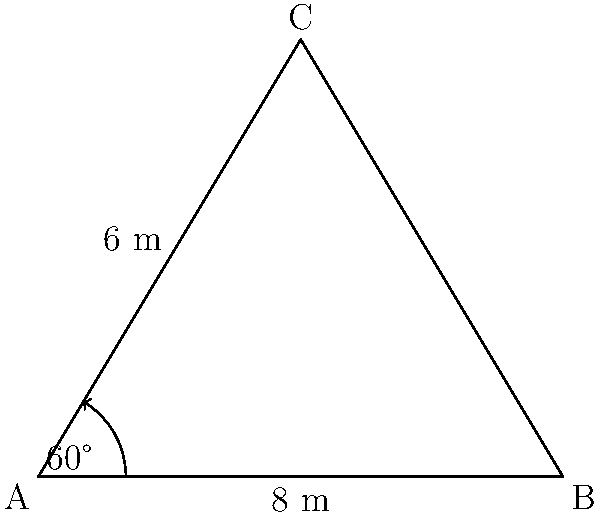In a hospice facility, you're planning to create a triangular garden to provide a peaceful space for patients and their families. Two sides of the garden measure 8 meters and 6 meters, with an included angle of 60°. What is the area of this triangular garden? To find the area of the triangular garden, we can use the formula for the area of a triangle given two sides and the included angle:

$$A = \frac{1}{2}ab\sin(C)$$

Where:
$A$ is the area of the triangle
$a$ and $b$ are the lengths of the two known sides
$C$ is the measure of the included angle

Given:
$a = 8$ meters
$b = 6$ meters
$C = 60°$

Step 1: Substitute the values into the formula:
$$A = \frac{1}{2} \cdot 8 \cdot 6 \cdot \sin(60°)$$

Step 2: Evaluate $\sin(60°)$:
$\sin(60°) = \frac{\sqrt{3}}{2}$

Step 3: Substitute this value and calculate:
$$A = \frac{1}{2} \cdot 8 \cdot 6 \cdot \frac{\sqrt{3}}{2}$$
$$A = 24 \cdot \frac{\sqrt{3}}{2}$$
$$A = 12\sqrt{3}$$

Step 4: Calculate the final value (rounded to two decimal places):
$$A \approx 20.78 \text{ square meters}$$

Therefore, the area of the triangular garden is approximately 20.78 square meters.
Answer: $20.78 \text{ m}^2$ 